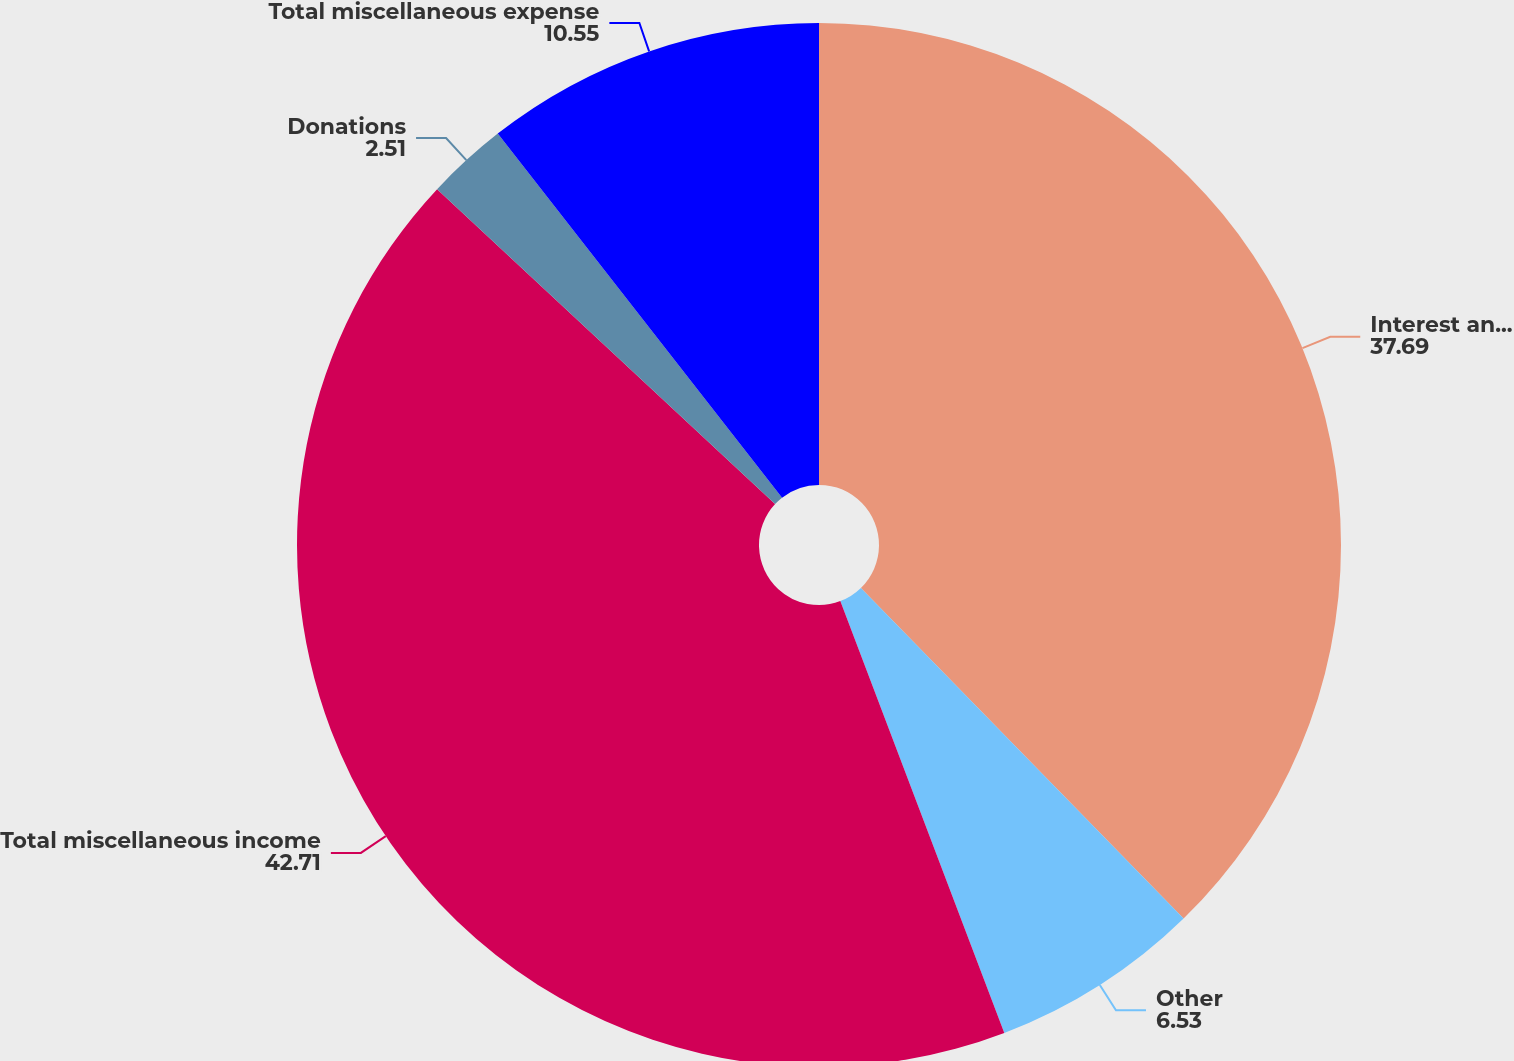Convert chart. <chart><loc_0><loc_0><loc_500><loc_500><pie_chart><fcel>Interest and dividend income<fcel>Other<fcel>Total miscellaneous income<fcel>Donations<fcel>Total miscellaneous expense<nl><fcel>37.69%<fcel>6.53%<fcel>42.71%<fcel>2.51%<fcel>10.55%<nl></chart> 